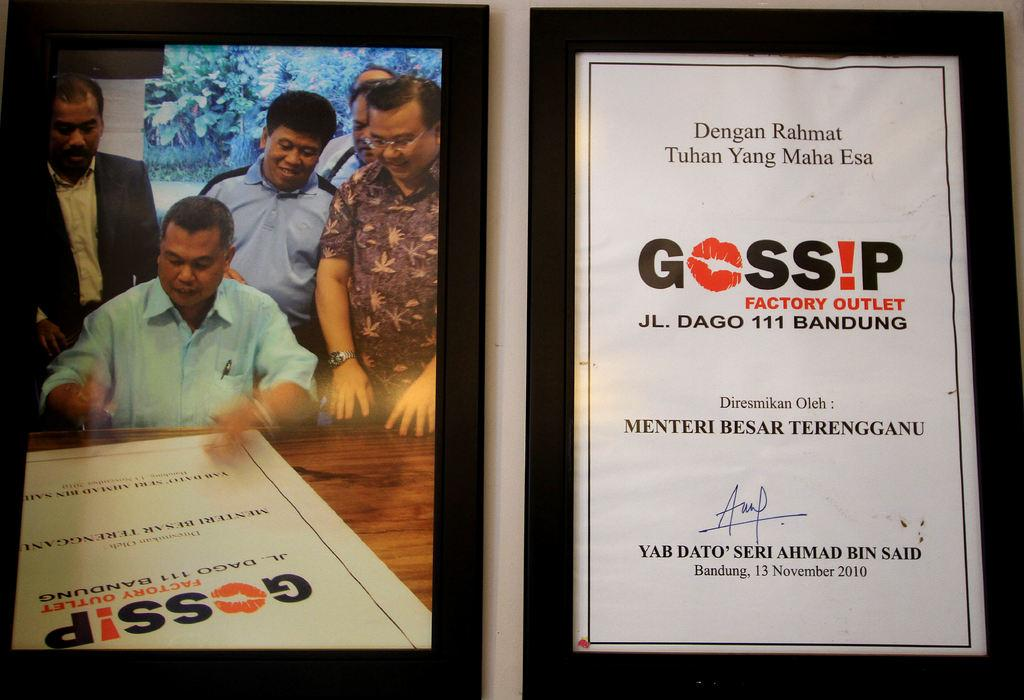Provide a one-sentence caption for the provided image. Men are looking a flyer with "Gossip Factory Outlet" in print. 